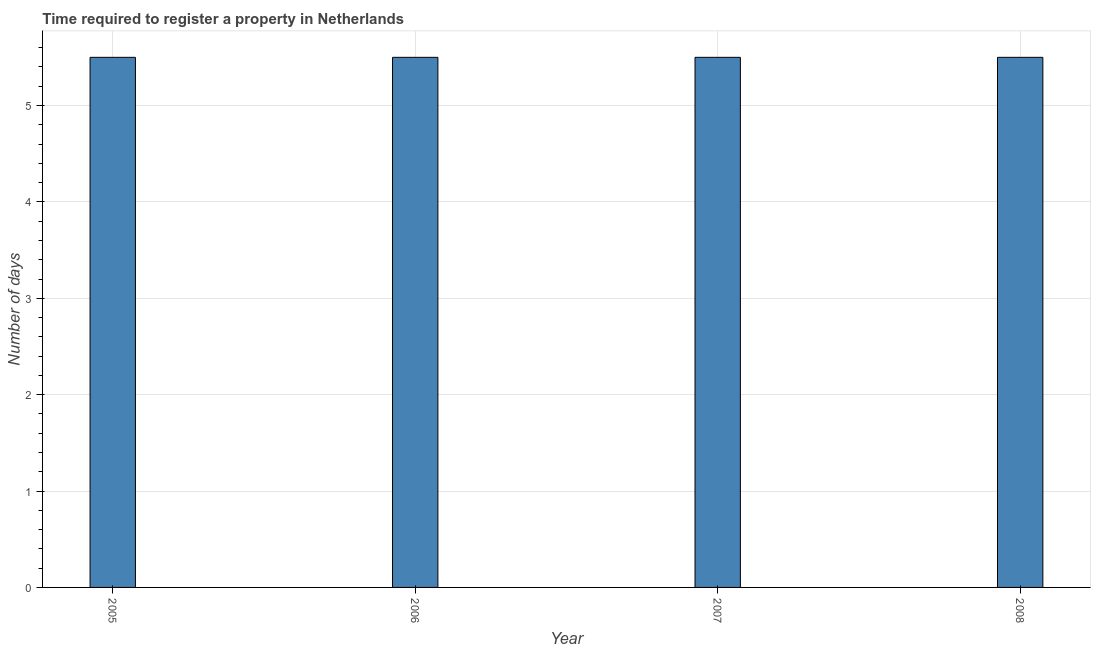Does the graph contain any zero values?
Make the answer very short. No. Does the graph contain grids?
Offer a terse response. Yes. What is the title of the graph?
Ensure brevity in your answer.  Time required to register a property in Netherlands. What is the label or title of the X-axis?
Make the answer very short. Year. What is the label or title of the Y-axis?
Provide a succinct answer. Number of days. Across all years, what is the maximum number of days required to register property?
Offer a terse response. 5.5. Across all years, what is the minimum number of days required to register property?
Ensure brevity in your answer.  5.5. What is the average number of days required to register property per year?
Make the answer very short. 5.5. Do a majority of the years between 2006 and 2005 (inclusive) have number of days required to register property greater than 0.8 days?
Offer a very short reply. No. Is the number of days required to register property in 2006 less than that in 2008?
Your answer should be compact. No. In how many years, is the number of days required to register property greater than the average number of days required to register property taken over all years?
Your answer should be compact. 0. How many bars are there?
Give a very brief answer. 4. What is the difference between two consecutive major ticks on the Y-axis?
Your answer should be compact. 1. What is the Number of days in 2005?
Ensure brevity in your answer.  5.5. What is the Number of days in 2006?
Offer a very short reply. 5.5. What is the Number of days of 2007?
Your answer should be compact. 5.5. What is the Number of days in 2008?
Give a very brief answer. 5.5. What is the difference between the Number of days in 2005 and 2006?
Offer a very short reply. 0. What is the difference between the Number of days in 2005 and 2007?
Provide a short and direct response. 0. What is the difference between the Number of days in 2006 and 2007?
Your answer should be compact. 0. What is the difference between the Number of days in 2006 and 2008?
Your answer should be compact. 0. What is the ratio of the Number of days in 2005 to that in 2008?
Your answer should be very brief. 1. What is the ratio of the Number of days in 2006 to that in 2007?
Offer a very short reply. 1. What is the ratio of the Number of days in 2006 to that in 2008?
Give a very brief answer. 1. What is the ratio of the Number of days in 2007 to that in 2008?
Ensure brevity in your answer.  1. 